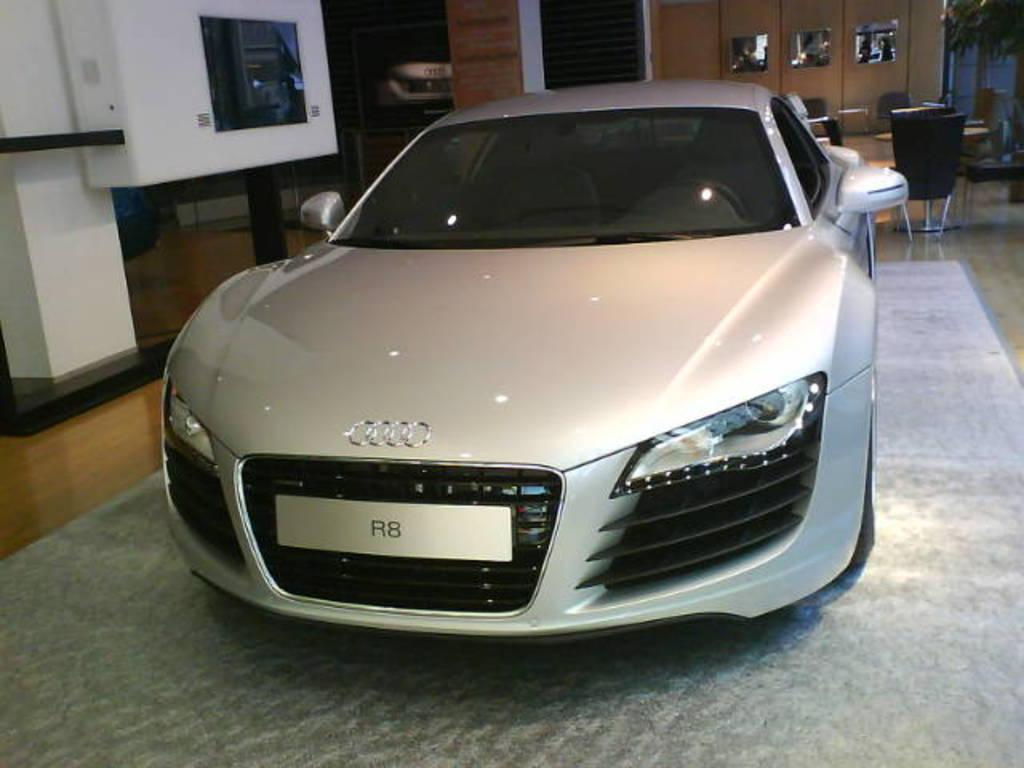What is the main object in the image? There is a car in the image. Where is the car located? The car is on the floor. What else can be seen behind the car? There are empty chairs behind the car. What architectural feature is visible in the image? There is a door visible in the image. What type of vegetation is present in the image? There is a plant in the image. What month is it in the image? The month cannot be determined from the image, as it does not contain any information about the time of year. 